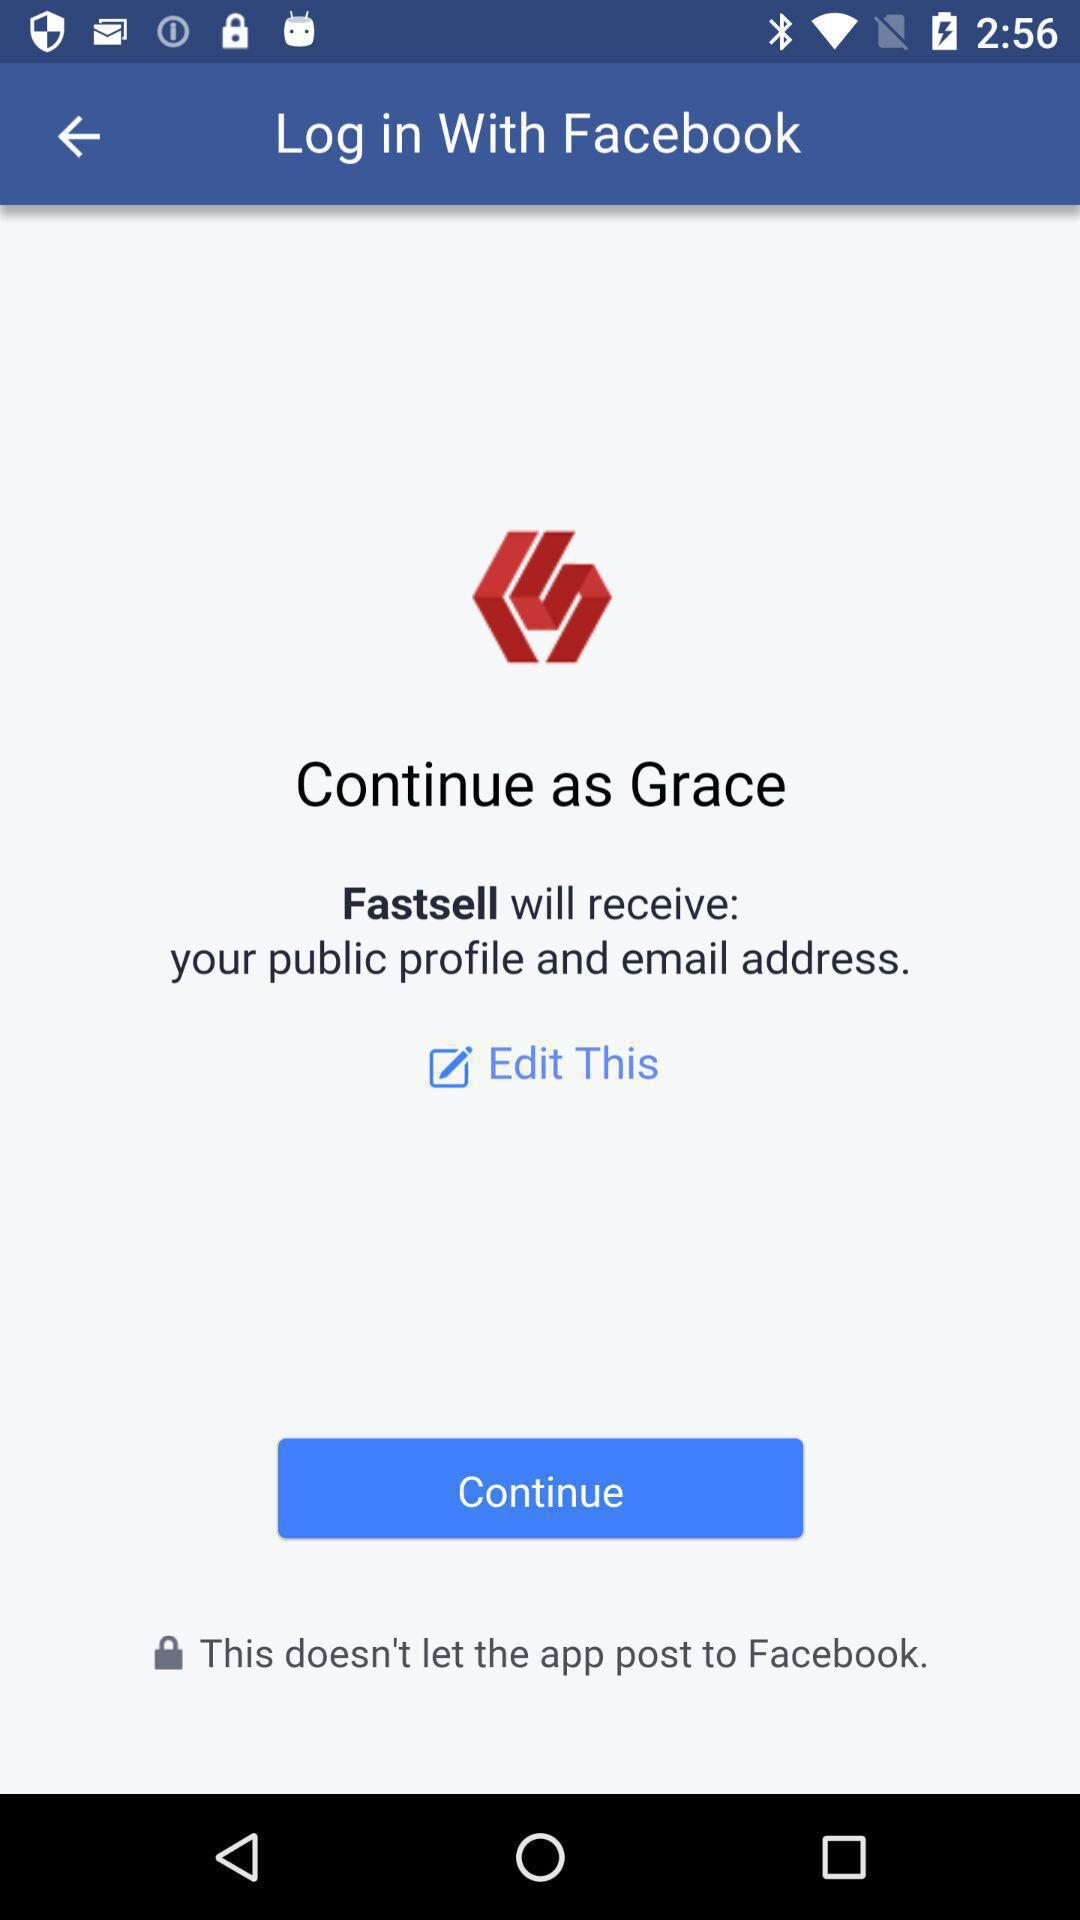What application will receive your public profile and email address? The application "Fastsell" will receive your public profile and email address. 